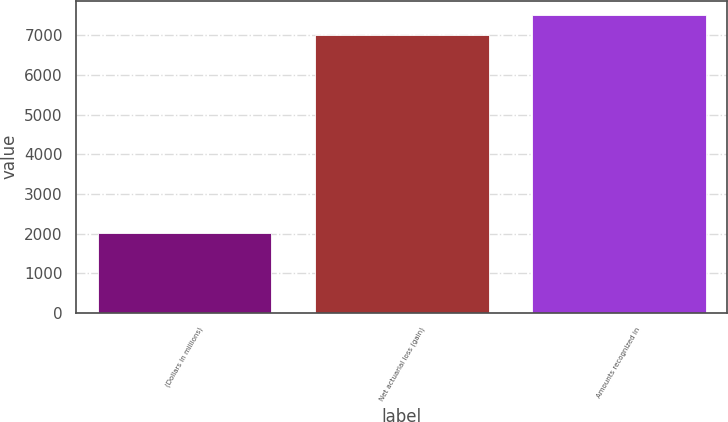Convert chart. <chart><loc_0><loc_0><loc_500><loc_500><bar_chart><fcel>(Dollars in millions)<fcel>Net actuarial loss (gain)<fcel>Amounts recognized in<nl><fcel>2012<fcel>6998<fcel>7500<nl></chart> 